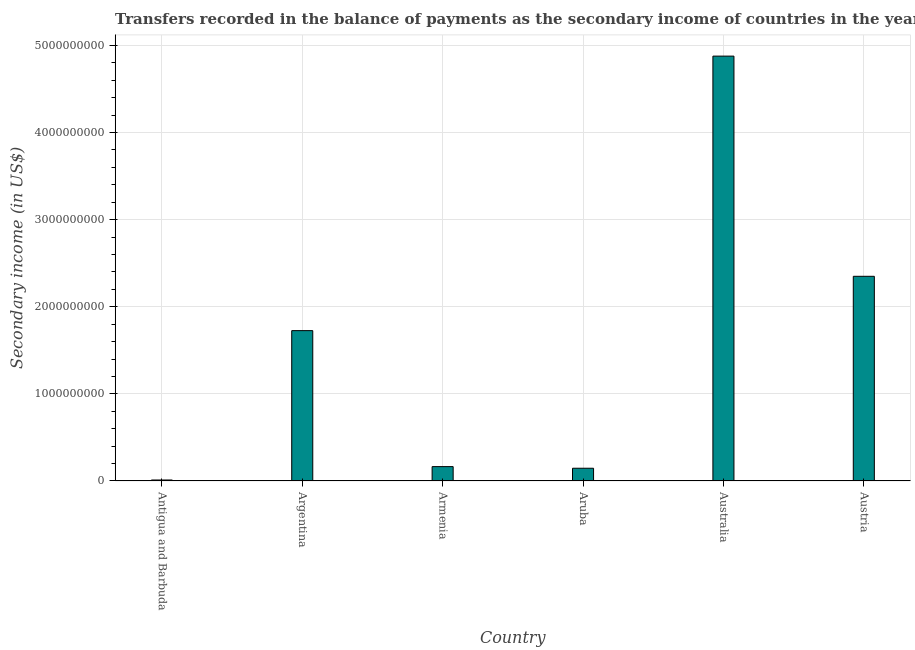Does the graph contain grids?
Offer a terse response. Yes. What is the title of the graph?
Offer a very short reply. Transfers recorded in the balance of payments as the secondary income of countries in the year 2009. What is the label or title of the Y-axis?
Provide a succinct answer. Secondary income (in US$). What is the amount of secondary income in Armenia?
Ensure brevity in your answer.  1.65e+08. Across all countries, what is the maximum amount of secondary income?
Offer a terse response. 4.88e+09. Across all countries, what is the minimum amount of secondary income?
Ensure brevity in your answer.  1.14e+07. In which country was the amount of secondary income minimum?
Offer a very short reply. Antigua and Barbuda. What is the sum of the amount of secondary income?
Your answer should be compact. 9.28e+09. What is the difference between the amount of secondary income in Antigua and Barbuda and Austria?
Ensure brevity in your answer.  -2.34e+09. What is the average amount of secondary income per country?
Make the answer very short. 1.55e+09. What is the median amount of secondary income?
Make the answer very short. 9.46e+08. In how many countries, is the amount of secondary income greater than 1800000000 US$?
Ensure brevity in your answer.  2. What is the ratio of the amount of secondary income in Argentina to that in Armenia?
Ensure brevity in your answer.  10.46. Is the amount of secondary income in Armenia less than that in Aruba?
Your response must be concise. No. Is the difference between the amount of secondary income in Armenia and Australia greater than the difference between any two countries?
Your answer should be compact. No. What is the difference between the highest and the second highest amount of secondary income?
Provide a short and direct response. 2.53e+09. What is the difference between the highest and the lowest amount of secondary income?
Keep it short and to the point. 4.87e+09. In how many countries, is the amount of secondary income greater than the average amount of secondary income taken over all countries?
Give a very brief answer. 3. How many bars are there?
Your response must be concise. 6. Are all the bars in the graph horizontal?
Provide a short and direct response. No. How many countries are there in the graph?
Keep it short and to the point. 6. What is the difference between two consecutive major ticks on the Y-axis?
Offer a very short reply. 1.00e+09. Are the values on the major ticks of Y-axis written in scientific E-notation?
Your answer should be compact. No. What is the Secondary income (in US$) of Antigua and Barbuda?
Offer a terse response. 1.14e+07. What is the Secondary income (in US$) of Argentina?
Provide a succinct answer. 1.73e+09. What is the Secondary income (in US$) in Armenia?
Ensure brevity in your answer.  1.65e+08. What is the Secondary income (in US$) of Aruba?
Give a very brief answer. 1.46e+08. What is the Secondary income (in US$) in Australia?
Provide a short and direct response. 4.88e+09. What is the Secondary income (in US$) of Austria?
Your answer should be compact. 2.35e+09. What is the difference between the Secondary income (in US$) in Antigua and Barbuda and Argentina?
Give a very brief answer. -1.71e+09. What is the difference between the Secondary income (in US$) in Antigua and Barbuda and Armenia?
Your answer should be very brief. -1.54e+08. What is the difference between the Secondary income (in US$) in Antigua and Barbuda and Aruba?
Your answer should be very brief. -1.35e+08. What is the difference between the Secondary income (in US$) in Antigua and Barbuda and Australia?
Give a very brief answer. -4.87e+09. What is the difference between the Secondary income (in US$) in Antigua and Barbuda and Austria?
Give a very brief answer. -2.34e+09. What is the difference between the Secondary income (in US$) in Argentina and Armenia?
Your answer should be compact. 1.56e+09. What is the difference between the Secondary income (in US$) in Argentina and Aruba?
Provide a short and direct response. 1.58e+09. What is the difference between the Secondary income (in US$) in Argentina and Australia?
Give a very brief answer. -3.15e+09. What is the difference between the Secondary income (in US$) in Argentina and Austria?
Provide a succinct answer. -6.24e+08. What is the difference between the Secondary income (in US$) in Armenia and Aruba?
Make the answer very short. 1.86e+07. What is the difference between the Secondary income (in US$) in Armenia and Australia?
Offer a very short reply. -4.71e+09. What is the difference between the Secondary income (in US$) in Armenia and Austria?
Offer a terse response. -2.18e+09. What is the difference between the Secondary income (in US$) in Aruba and Australia?
Offer a very short reply. -4.73e+09. What is the difference between the Secondary income (in US$) in Aruba and Austria?
Your response must be concise. -2.20e+09. What is the difference between the Secondary income (in US$) in Australia and Austria?
Offer a very short reply. 2.53e+09. What is the ratio of the Secondary income (in US$) in Antigua and Barbuda to that in Argentina?
Provide a short and direct response. 0.01. What is the ratio of the Secondary income (in US$) in Antigua and Barbuda to that in Armenia?
Provide a succinct answer. 0.07. What is the ratio of the Secondary income (in US$) in Antigua and Barbuda to that in Aruba?
Offer a terse response. 0.08. What is the ratio of the Secondary income (in US$) in Antigua and Barbuda to that in Australia?
Your answer should be very brief. 0. What is the ratio of the Secondary income (in US$) in Antigua and Barbuda to that in Austria?
Your response must be concise. 0.01. What is the ratio of the Secondary income (in US$) in Argentina to that in Armenia?
Offer a terse response. 10.46. What is the ratio of the Secondary income (in US$) in Argentina to that in Aruba?
Provide a succinct answer. 11.79. What is the ratio of the Secondary income (in US$) in Argentina to that in Australia?
Your answer should be compact. 0.35. What is the ratio of the Secondary income (in US$) in Argentina to that in Austria?
Give a very brief answer. 0.73. What is the ratio of the Secondary income (in US$) in Armenia to that in Aruba?
Offer a terse response. 1.13. What is the ratio of the Secondary income (in US$) in Armenia to that in Australia?
Your answer should be very brief. 0.03. What is the ratio of the Secondary income (in US$) in Armenia to that in Austria?
Your answer should be very brief. 0.07. What is the ratio of the Secondary income (in US$) in Aruba to that in Australia?
Offer a very short reply. 0.03. What is the ratio of the Secondary income (in US$) in Aruba to that in Austria?
Give a very brief answer. 0.06. What is the ratio of the Secondary income (in US$) in Australia to that in Austria?
Ensure brevity in your answer.  2.08. 